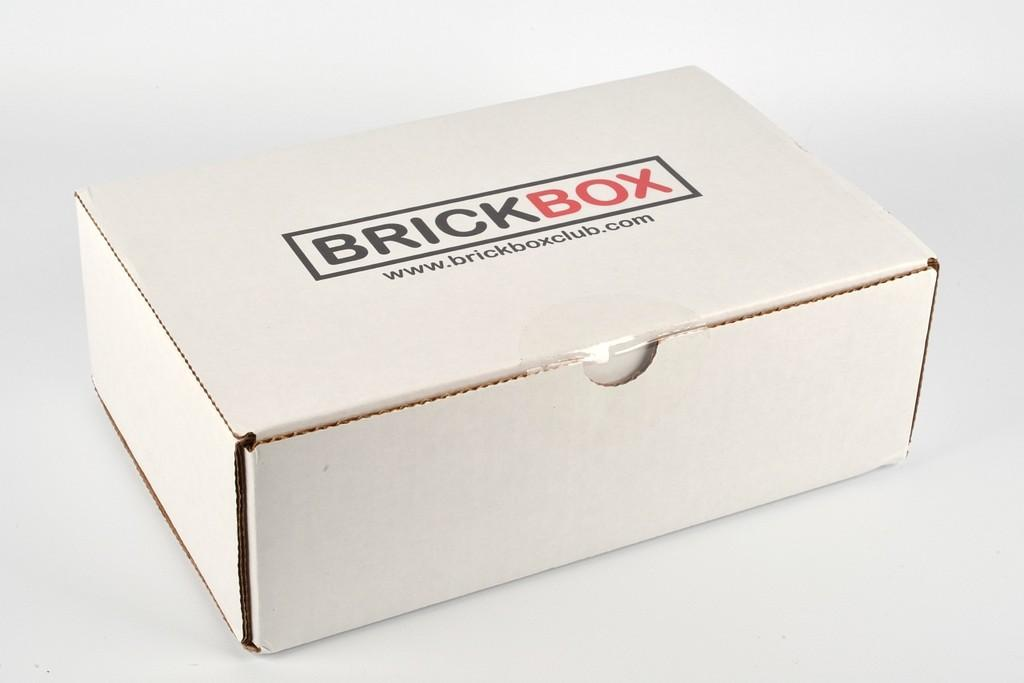<image>
Describe the image concisely. A white box with Brick Box written on it and the web address for Brick Box. 